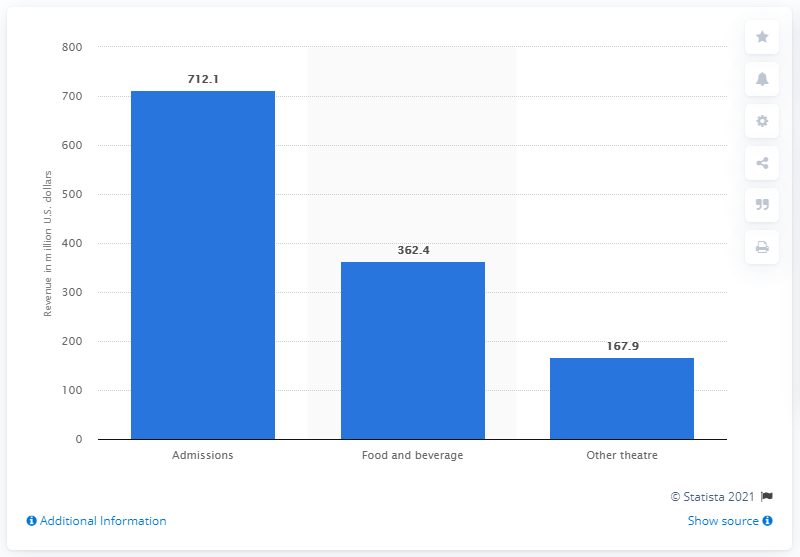Give some essential details in this illustration. AMC Theatres generated approximately $362.4 million in revenue in 2020. The value of food and beverage is 362.4. Admissions at this theatre are significantly higher than other theatres, with a percentage increase of 544.2%. 